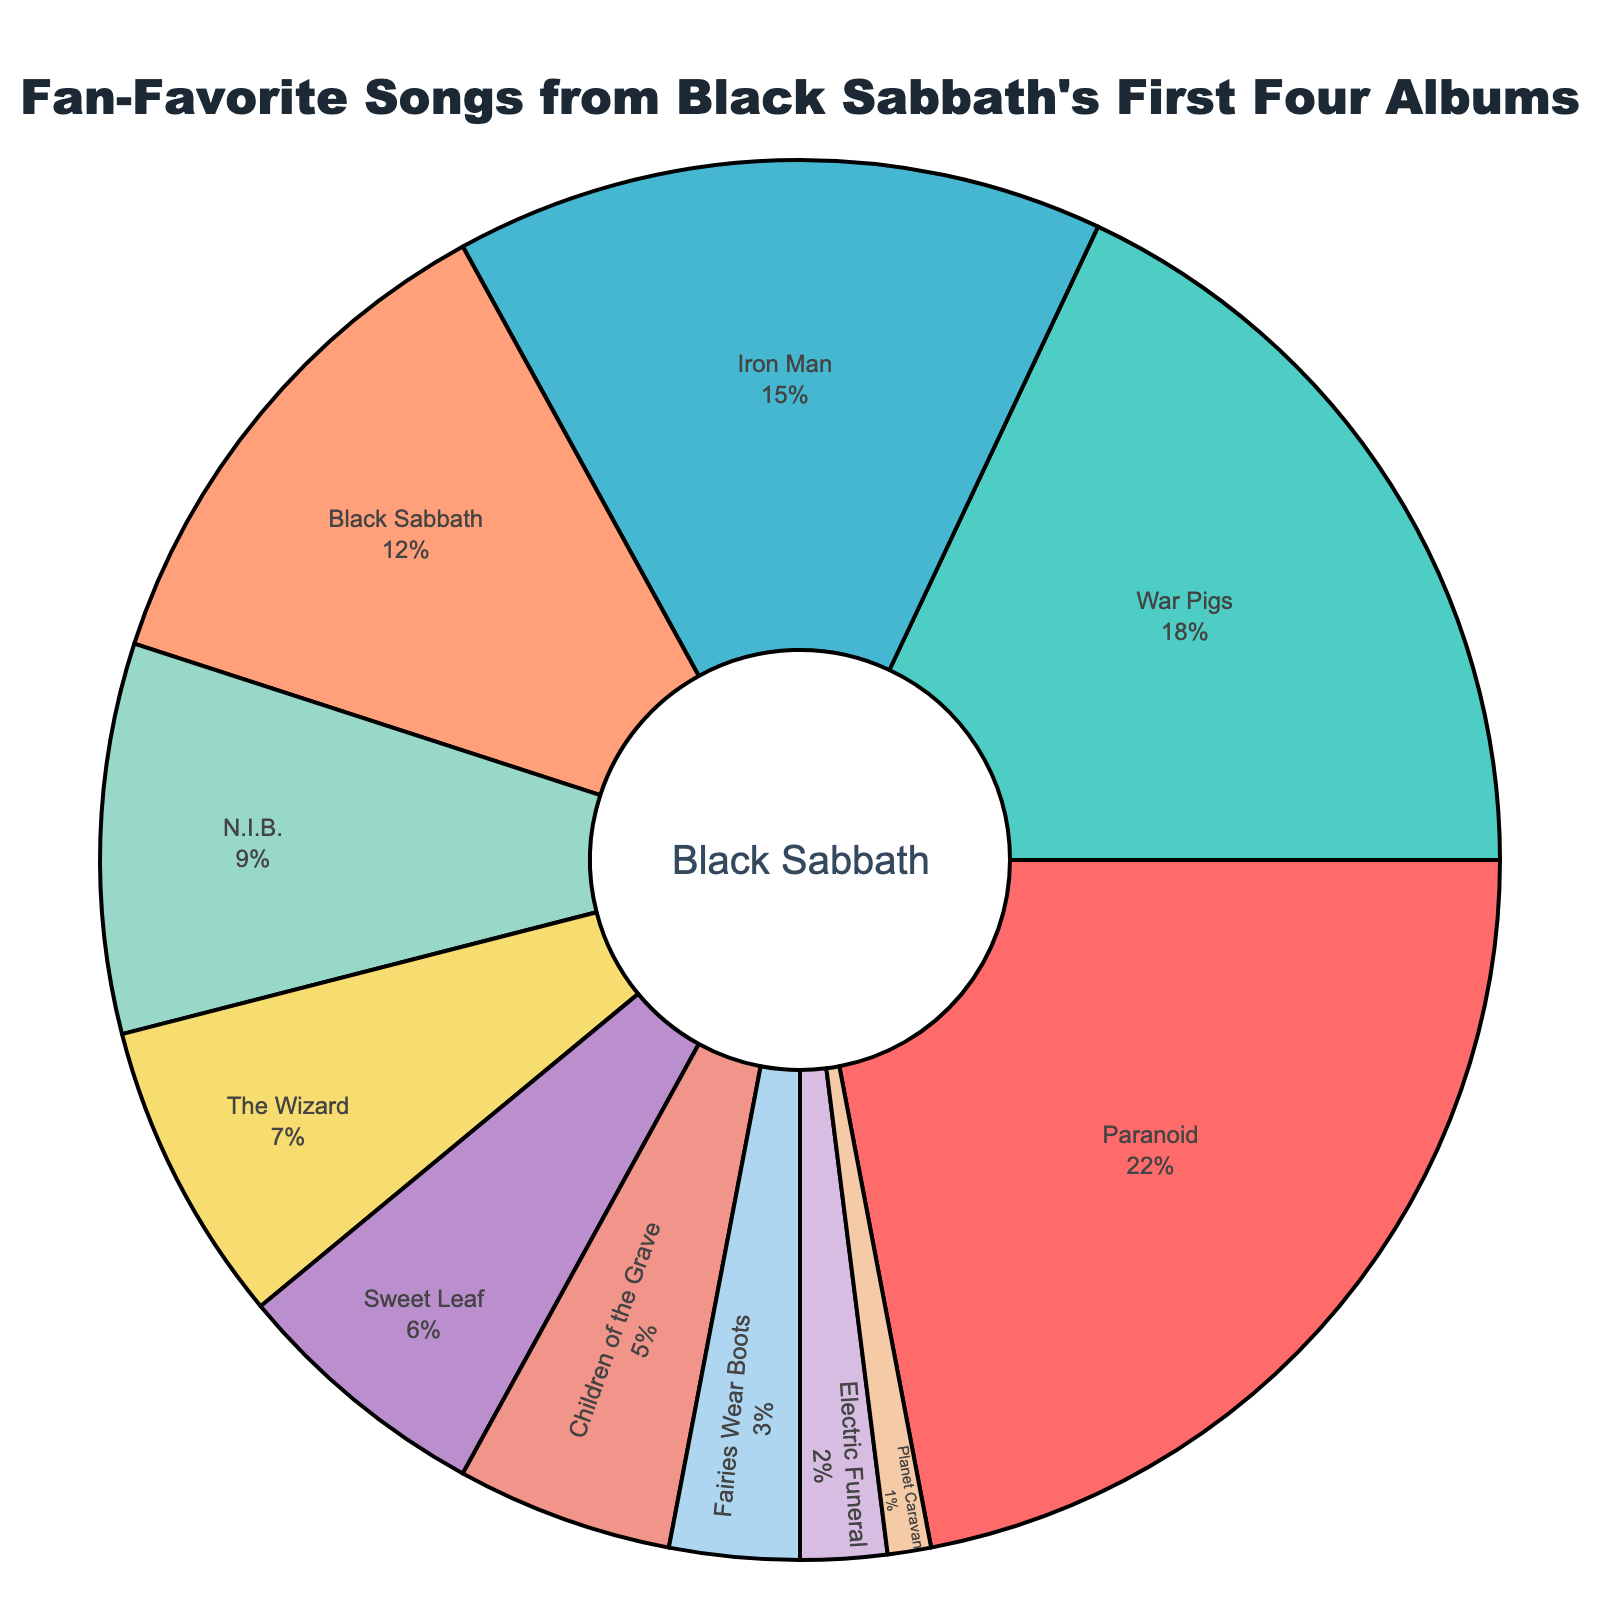Which song has the majority fan vote? "Paranoid" gets the highest percentage on the pie chart, occupying the largest slice with 22%.
Answer: Paranoid Which songs have a combined percentage of more than 30%? "Paranoid" and "War Pigs" together have percentages of 22% and 18% respectively. 22% + 18% = 40%, which is more than 30%.
Answer: Paranoid, War Pigs Which song occupies the smallest slice of the pie chart? "Planet Caravan" occupies the smallest slice with 1%.
Answer: Planet Caravan Are there more people who favor "Iron Man" or those who favor "N.I.B." and "The Wizard" combined? The percentage for "Iron Man" is 15%. The combined percentage for "N.I.B." (9%) and "The Wizard" (7%) is 9% + 7% = 16%, which is greater than 15% for "Iron Man."
Answer: N.I.B. and The Wizard Which song has nearly double the fan percentage compared to "Sweet Leaf"? "Iron Man" has 15%, which is two and a half times more than "Sweet Leaf's" 6%.
Answer: Iron Man What is the total percentage of votes for songs from the first two albums? The songs from the first album are "Black Sabbath" (12%), "N.I.B." (9%), "The Wizard" (7%), and "Behind the Wall of Sleep" (3%). Their total is 12% + 9% + 7% + 3% = 31%. The songs from the second album are "Paranoid" (22%), "War Pigs" (18%), "Iron Man" (15%), "Fairies Wear Boots" (3%), and "Planet Caravan" (1%). Their total is 22% + 18% + 15% + 3% + 1% = 59%. The combined total is 31% + 59% = 90%.
Answer: 90% Which song has exactly half the fan percentage compared to "Paranoid"? "War Pigs" has 18%, which is somewhat close to but not exactly half of "Paranoid"'s 22%.
Answer: None 